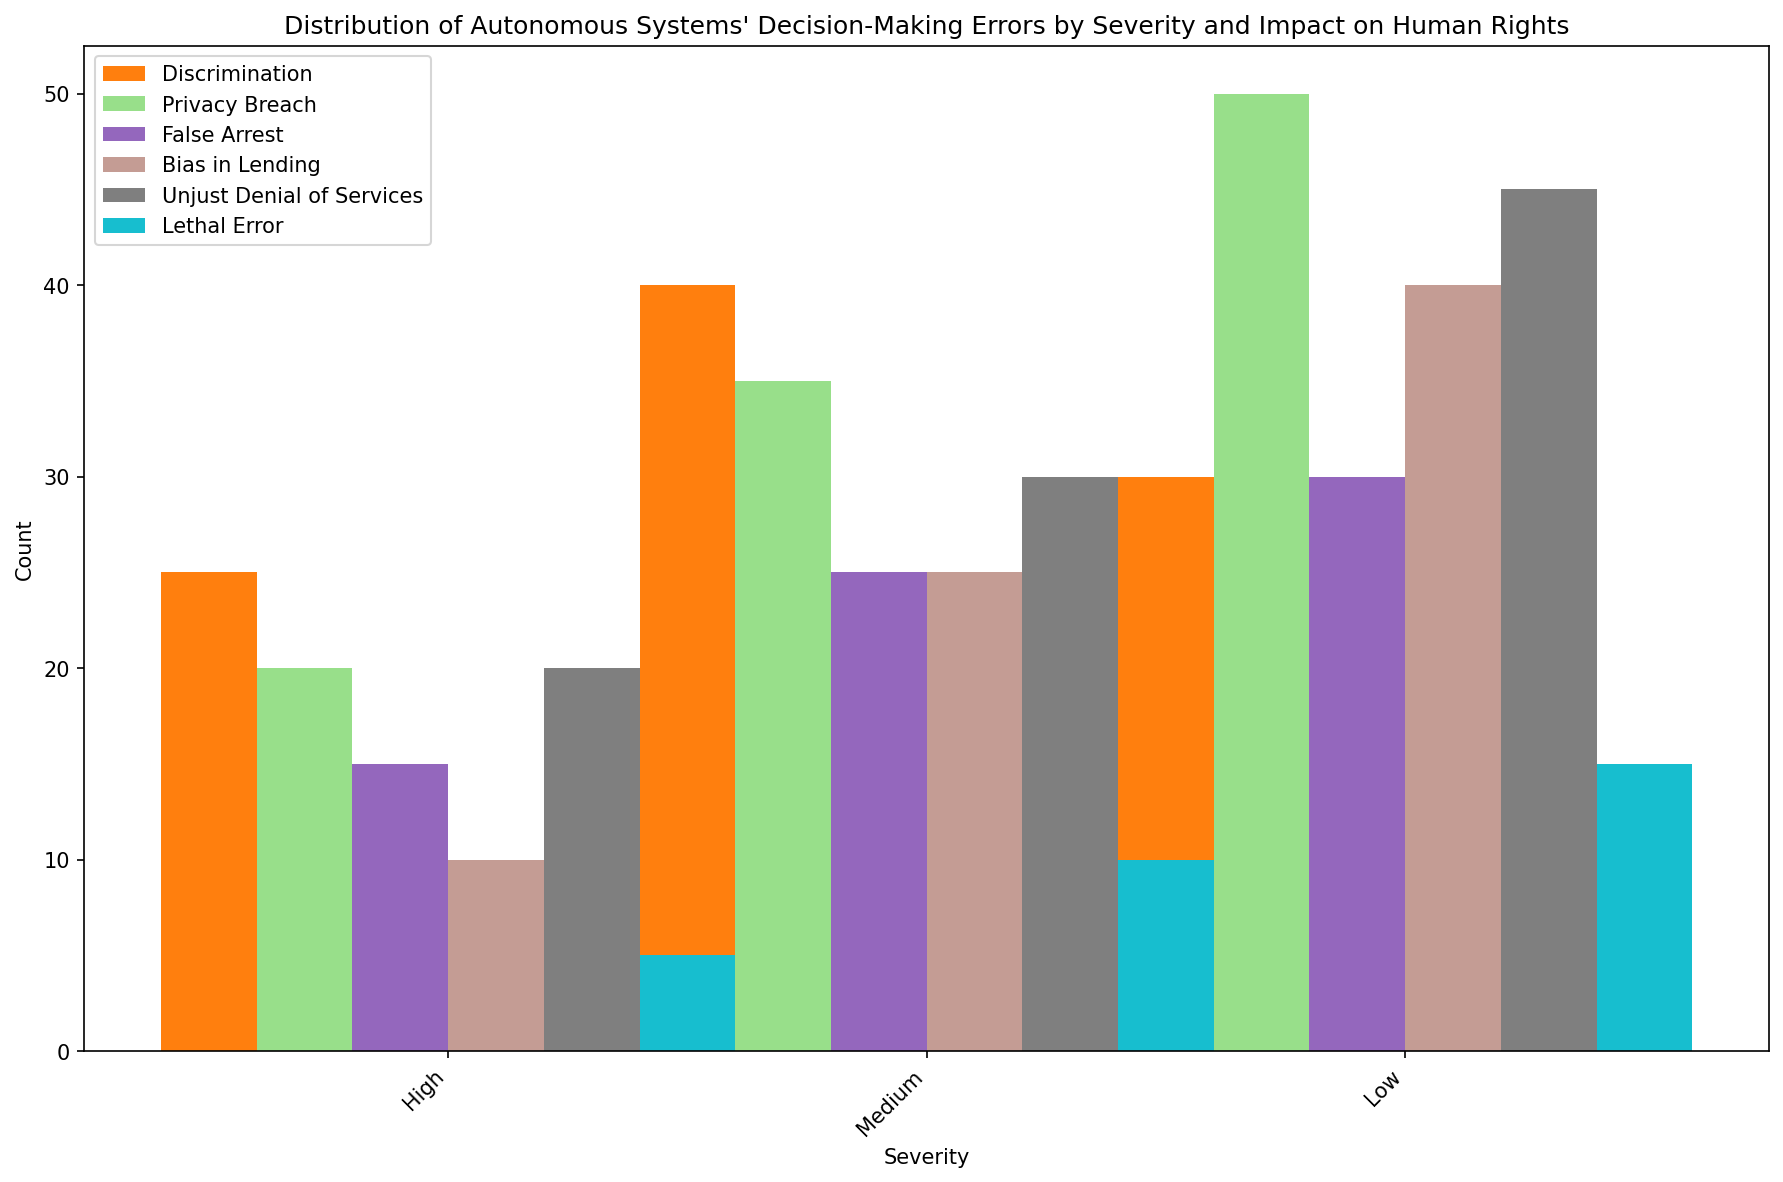What's the total number of errors categorized under "Discrimination"? Add the counts of all "Discrimination" errors across different severities: High (25), Medium (40), and Low (30). The total is 25 + 40 + 30 = 95.
Answer: 95 Which category has the highest number of "High" severity errors? Compare the counts of "High" severity errors across all categories: Discrimination (25), Privacy Breach (20), False Arrest (15), Bias in Lending (10), Unjust Denial of Services (20), and Lethal Error (5). The highest count is for "Discrimination" with 25.
Answer: Discrimination What is the average number of errors for categories with a "Medium" severity? Add the counts of "Medium" severity errors across all categories: Discrimination (40), Privacy Breach (35), False Arrest (25), Bias in Lending (25), Unjust Denial of Services (30), and Lethal Error (10). The total is 40 + 35 + 25 + 25 + 30 + 10 = 165. There are 6 categories, so the average is 165 / 6 = 27.5.
Answer: 27.5 Which category has the least number of "Critical" impact errors? Compare the counts of "Critical" impact errors: Discrimination (25) and Lethal Error (10). The least count is for "Lethal Error" with 10.
Answer: Lethal Error What is the ratio of "Low" severity errors in "Privacy Breach" compared to "Bias in Lending"? The count of "Low" severity errors in "Privacy Breach" is 50, and in "Bias in Lending" is 40. The ratio is 50 / 40 = 1.25.
Answer: 1.25 How do the counts of "High" severity errors in "False Arrest" and "Unjust Denial of Services" compare? Compare the counts of "High" severity errors for "False Arrest" (15) and "Unjust Denial of Services" (20). "Unjust Denial of Services" has more errors than "False Arrest".
Answer: Unjust Denial of Services Which category has the highest "Minimal" impact errors? Compare the counts of "Low" severity (Minimal impact) errors: Privacy Breach (50), Bias in Lending (40), and Unjust Denial of Services (45). "Privacy Breach" has the highest count with 50.
Answer: Privacy Breach What's the sum of "Moderate" impact errors across all categories? Add the counts of "Moderate" impact errors across all categories: Discrimination (30), Privacy Breach (35), False Arrest (30), Bias in Lending (25), and Unjust Denial of Services (30). The total is 30 + 35 + 30 + 25 + 30 = 150.
Answer: 150 Which category has the highest cumulative number of errors? Sum the counts of all severities for each category:
- Discrimination: 25 + 40 + 30 = 95
- Privacy Breach: 20 + 35 + 50 = 105
- False Arrest: 15 + 25 + 30 = 70
- Bias in Lending: 10 + 25 + 40 = 75
- Unjust Denial of Services: 20 + 30 + 45 = 95
- Lethal Error: 5 + 10 + 15 = 30 
The highest cumulative number of errors is "Privacy Breach" with 105.
Answer: Privacy Breach How many categories have "High" severity errors impacting human rights as "Critical"? From the data, only "Discrimination" (25) and "False Arrest" (15) have "High" severity errors impacting human rights as "Critical". There are 2 categories.
Answer: 2 